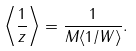Convert formula to latex. <formula><loc_0><loc_0><loc_500><loc_500>\left \langle \frac { 1 } { z } \right \rangle = \frac { 1 } { M \langle 1 / W \rangle } .</formula> 